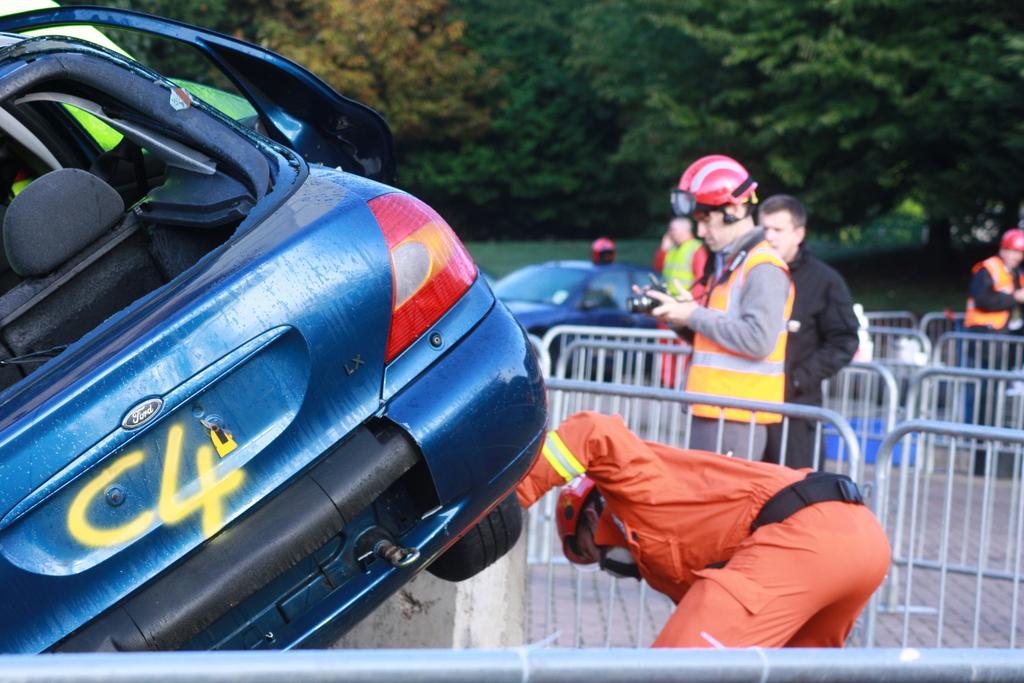In one or two sentences, can you explain what this image depicts? In this image we can see blue color car. Beside one man is bending. Right side of the image railing and people are standing. Background of the image trees are present. In the middle of the image one more car is there. 